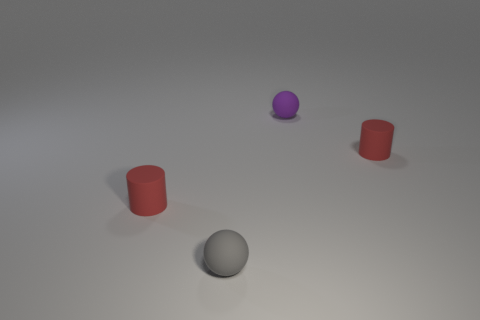Add 4 small objects. How many objects exist? 8 Subtract all cyan spheres. Subtract all yellow cylinders. How many spheres are left? 2 Subtract 0 purple cylinders. How many objects are left? 4 Subtract all small purple matte objects. Subtract all small rubber balls. How many objects are left? 1 Add 3 purple rubber things. How many purple rubber things are left? 4 Add 3 tiny gray rubber balls. How many tiny gray rubber balls exist? 4 